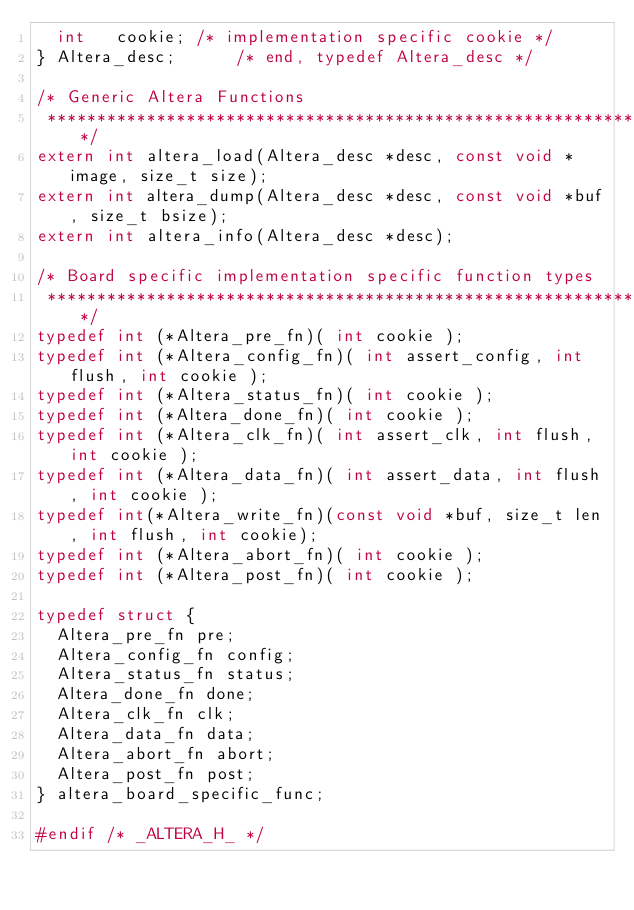<code> <loc_0><loc_0><loc_500><loc_500><_C_>	int		cookie;	/* implementation specific cookie */
} Altera_desc;			/* end, typedef Altera_desc */

/* Generic Altera Functions
 *********************************************************************/
extern int altera_load(Altera_desc *desc, const void *image, size_t size);
extern int altera_dump(Altera_desc *desc, const void *buf, size_t bsize);
extern int altera_info(Altera_desc *desc);

/* Board specific implementation specific function types
 *********************************************************************/
typedef int (*Altera_pre_fn)( int cookie );
typedef int (*Altera_config_fn)( int assert_config, int flush, int cookie );
typedef int (*Altera_status_fn)( int cookie );
typedef int (*Altera_done_fn)( int cookie );
typedef int (*Altera_clk_fn)( int assert_clk, int flush, int cookie );
typedef int (*Altera_data_fn)( int assert_data, int flush, int cookie );
typedef int(*Altera_write_fn)(const void *buf, size_t len, int flush, int cookie);
typedef int (*Altera_abort_fn)( int cookie );
typedef int (*Altera_post_fn)( int cookie );

typedef struct {
	Altera_pre_fn pre;
	Altera_config_fn config;
	Altera_status_fn status;
	Altera_done_fn done;
	Altera_clk_fn clk;
	Altera_data_fn data;
	Altera_abort_fn abort;
	Altera_post_fn post;
} altera_board_specific_func;

#endif /* _ALTERA_H_ */
</code> 